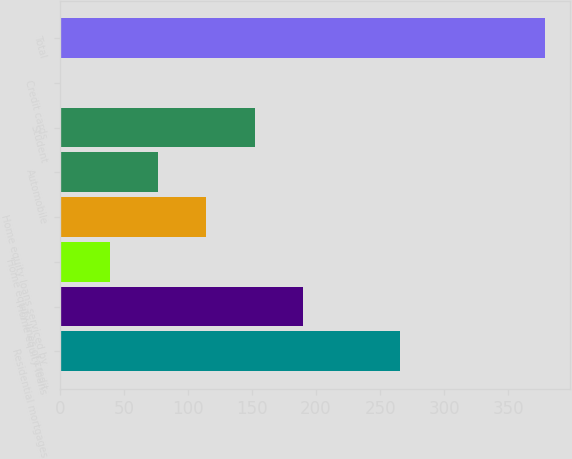<chart> <loc_0><loc_0><loc_500><loc_500><bar_chart><fcel>Residential mortgages<fcel>Home equity loans<fcel>Home equity lines of credit<fcel>Home equity loans serviced by<fcel>Automobile<fcel>Student<fcel>Credit cards<fcel>Total<nl><fcel>265.6<fcel>190<fcel>38.8<fcel>114.4<fcel>76.6<fcel>152.2<fcel>1<fcel>379<nl></chart> 